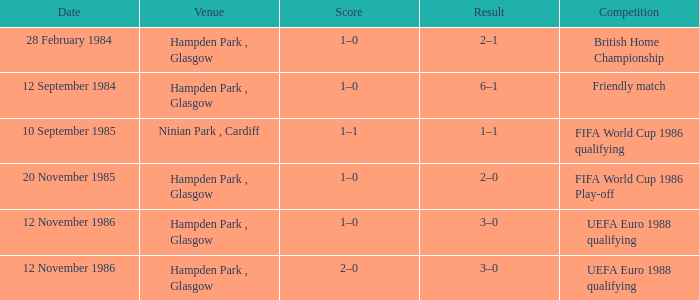Can you provide the scores from the 1986 fifa world cup qualifying competition? 1–1. 